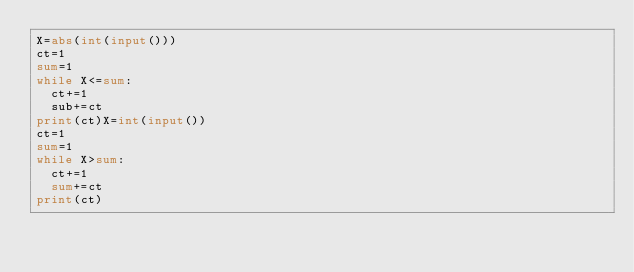Convert code to text. <code><loc_0><loc_0><loc_500><loc_500><_Python_>X=abs(int(input()))
ct=1
sum=1
while X<=sum:
  ct+=1
  sub+=ct
print(ct)X=int(input())
ct=1
sum=1
while X>sum:
  ct+=1
  sum+=ct
print(ct)</code> 